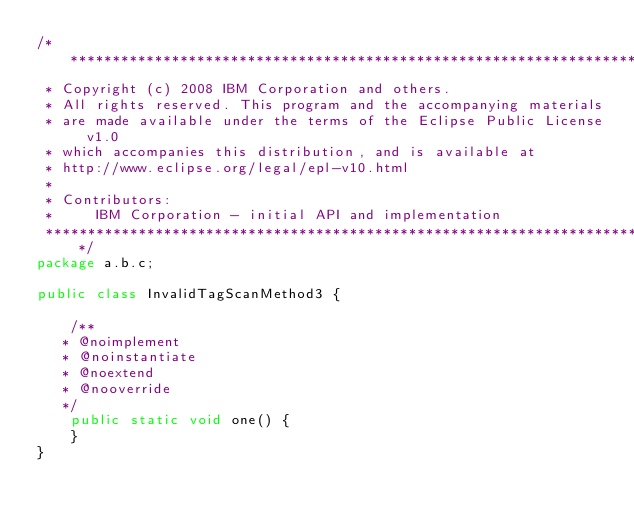Convert code to text. <code><loc_0><loc_0><loc_500><loc_500><_Java_>/*******************************************************************************
 * Copyright (c) 2008 IBM Corporation and others.
 * All rights reserved. This program and the accompanying materials
 * are made available under the terms of the Eclipse Public License v1.0
 * which accompanies this distribution, and is available at
 * http://www.eclipse.org/legal/epl-v10.html
 * 
 * Contributors:
 *     IBM Corporation - initial API and implementation
 *******************************************************************************/
package a.b.c;

public class InvalidTagScanMethod3 {

    /**
	 * @noimplement
	 * @noinstantiate
	 * @noextend
	 * @nooverride
	 */
    public static void one() {
    }
}
</code> 